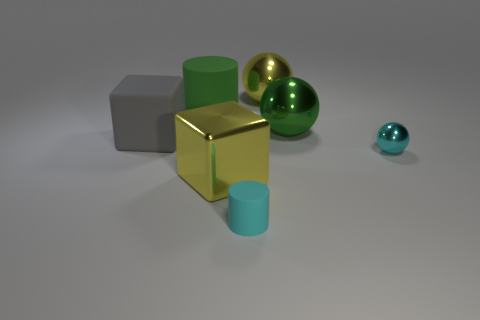Subtract all cyan shiny balls. How many balls are left? 2 Add 2 cubes. How many objects exist? 9 Subtract all balls. How many objects are left? 4 Subtract 1 spheres. How many spheres are left? 2 Subtract all cyan cylinders. How many cylinders are left? 1 Subtract all yellow blocks. Subtract all tiny shiny objects. How many objects are left? 5 Add 6 green matte objects. How many green matte objects are left? 7 Add 1 large rubber cubes. How many large rubber cubes exist? 2 Subtract 0 blue blocks. How many objects are left? 7 Subtract all green cylinders. Subtract all brown spheres. How many cylinders are left? 1 